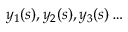Convert formula to latex. <formula><loc_0><loc_0><loc_500><loc_500>y _ { 1 } ( s ) , y _ { 2 } ( s ) , y _ { 3 } ( s ) \dots</formula> 